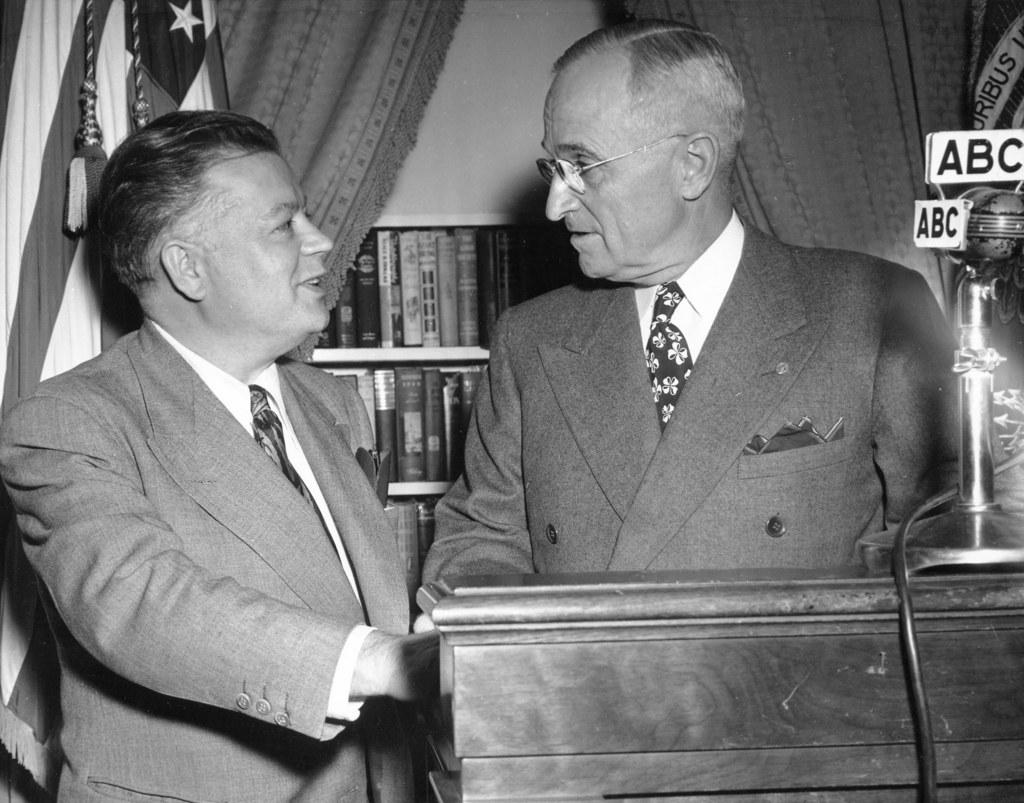<image>
Describe the image concisely. Someone is speaking to President Harry S. Truman at a podium near a microphone belonging to the ABC network. 